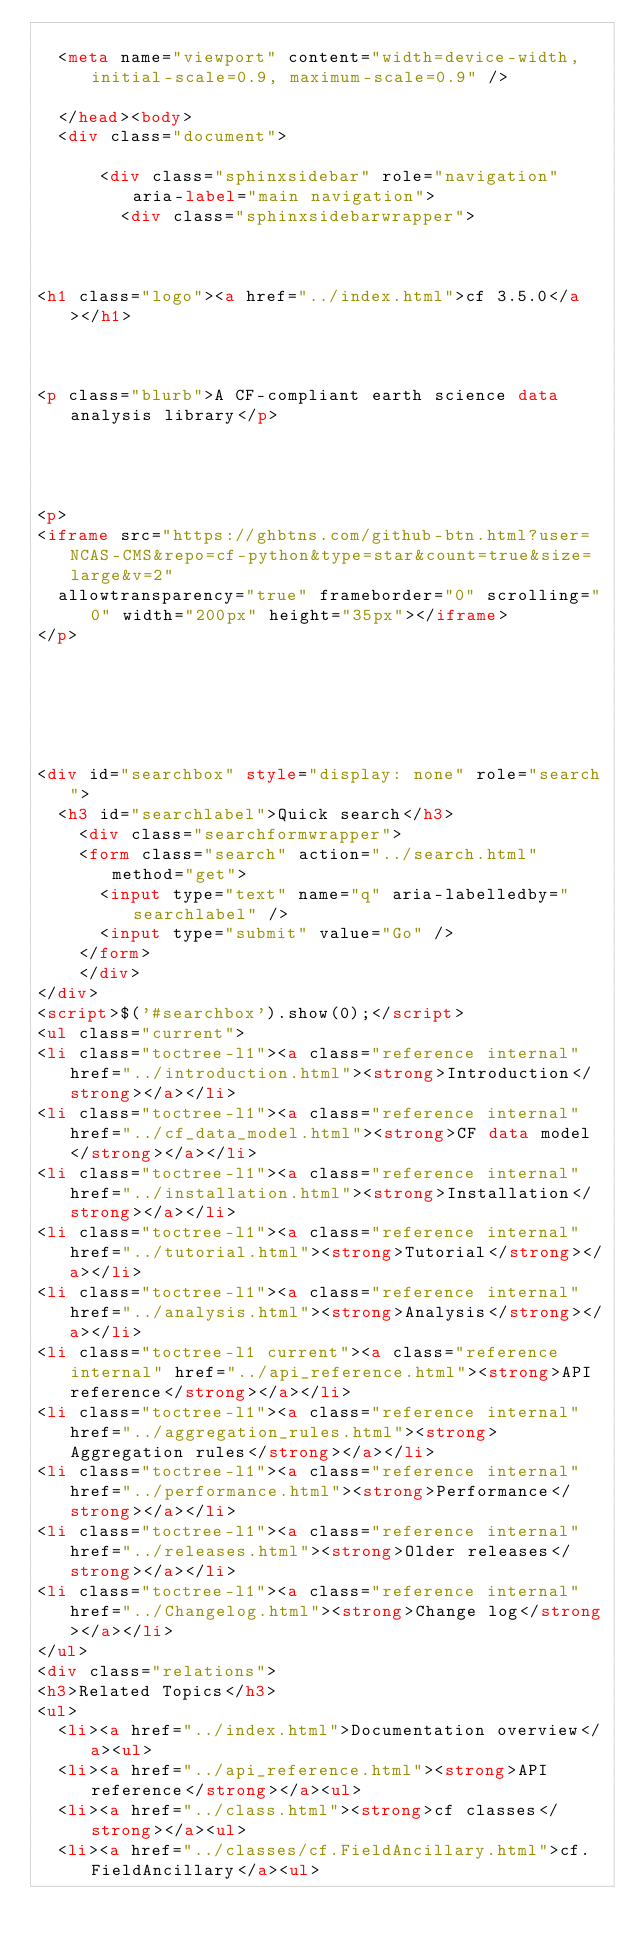<code> <loc_0><loc_0><loc_500><loc_500><_HTML_>  
  <meta name="viewport" content="width=device-width, initial-scale=0.9, maximum-scale=0.9" />

  </head><body>
  <div class="document">
    
      <div class="sphinxsidebar" role="navigation" aria-label="main navigation">
        <div class="sphinxsidebarwrapper">



<h1 class="logo"><a href="../index.html">cf 3.5.0</a></h1>



<p class="blurb">A CF-compliant earth science data analysis library</p>




<p>
<iframe src="https://ghbtns.com/github-btn.html?user=NCAS-CMS&repo=cf-python&type=star&count=true&size=large&v=2"
  allowtransparency="true" frameborder="0" scrolling="0" width="200px" height="35px"></iframe>
</p>






<div id="searchbox" style="display: none" role="search">
  <h3 id="searchlabel">Quick search</h3>
    <div class="searchformwrapper">
    <form class="search" action="../search.html" method="get">
      <input type="text" name="q" aria-labelledby="searchlabel" />
      <input type="submit" value="Go" />
    </form>
    </div>
</div>
<script>$('#searchbox').show(0);</script>
<ul class="current">
<li class="toctree-l1"><a class="reference internal" href="../introduction.html"><strong>Introduction</strong></a></li>
<li class="toctree-l1"><a class="reference internal" href="../cf_data_model.html"><strong>CF data model</strong></a></li>
<li class="toctree-l1"><a class="reference internal" href="../installation.html"><strong>Installation</strong></a></li>
<li class="toctree-l1"><a class="reference internal" href="../tutorial.html"><strong>Tutorial</strong></a></li>
<li class="toctree-l1"><a class="reference internal" href="../analysis.html"><strong>Analysis</strong></a></li>
<li class="toctree-l1 current"><a class="reference internal" href="../api_reference.html"><strong>API reference</strong></a></li>
<li class="toctree-l1"><a class="reference internal" href="../aggregation_rules.html"><strong>Aggregation rules</strong></a></li>
<li class="toctree-l1"><a class="reference internal" href="../performance.html"><strong>Performance</strong></a></li>
<li class="toctree-l1"><a class="reference internal" href="../releases.html"><strong>Older releases</strong></a></li>
<li class="toctree-l1"><a class="reference internal" href="../Changelog.html"><strong>Change log</strong></a></li>
</ul>
<div class="relations">
<h3>Related Topics</h3>
<ul>
  <li><a href="../index.html">Documentation overview</a><ul>
  <li><a href="../api_reference.html"><strong>API reference</strong></a><ul>
  <li><a href="../class.html"><strong>cf classes</strong></a><ul>
  <li><a href="../classes/cf.FieldAncillary.html">cf.FieldAncillary</a><ul></code> 